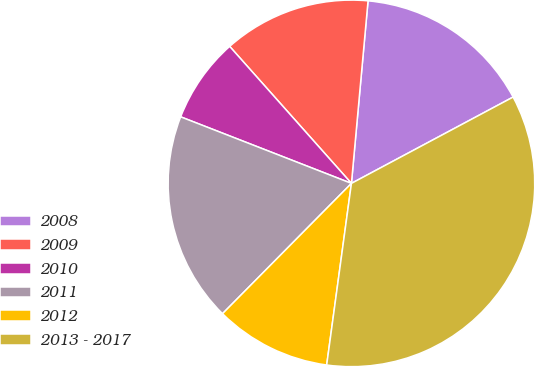Convert chart. <chart><loc_0><loc_0><loc_500><loc_500><pie_chart><fcel>2008<fcel>2009<fcel>2010<fcel>2011<fcel>2012<fcel>2013 - 2017<nl><fcel>15.75%<fcel>13.01%<fcel>7.52%<fcel>18.5%<fcel>10.26%<fcel>34.96%<nl></chart> 